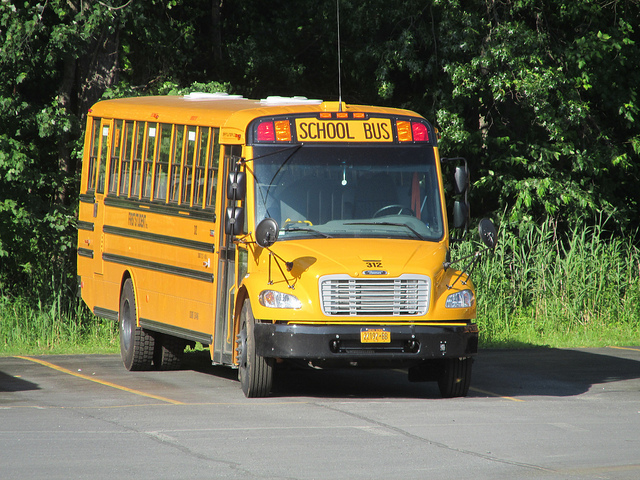Identify the text contained in this image. SCHOOL BUS 